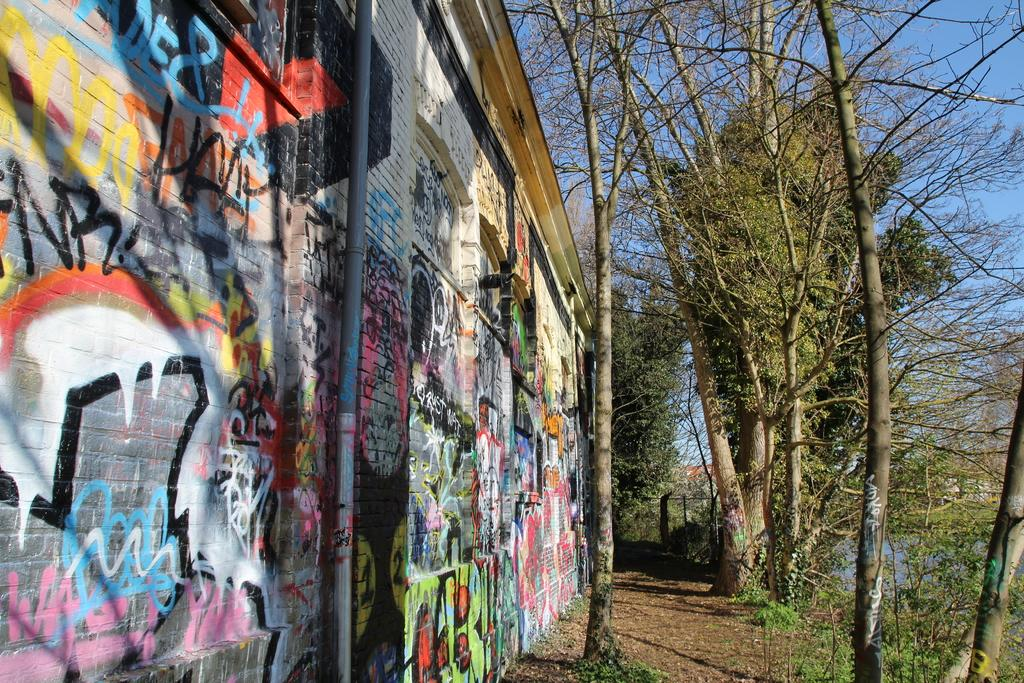What is the color of the wall in the image? The wall in the image is multi-colored. What can be seen in the background of the image? There are trees in the background of the image, and they are green. What color is the sky in the image? The sky in the image is blue. What type of account is being discussed in the image? There is no account being discussed in the image; it features a multi-colored wall, green trees in the background, and a blue sky. What kind of art is being created in the image? There is no art being created in the image; it simply depicts a wall, trees, and the sky. 